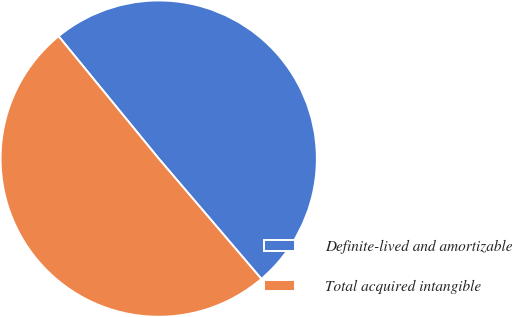<chart> <loc_0><loc_0><loc_500><loc_500><pie_chart><fcel>Definite-lived and amortizable<fcel>Total acquired intangible<nl><fcel>49.67%<fcel>50.33%<nl></chart> 